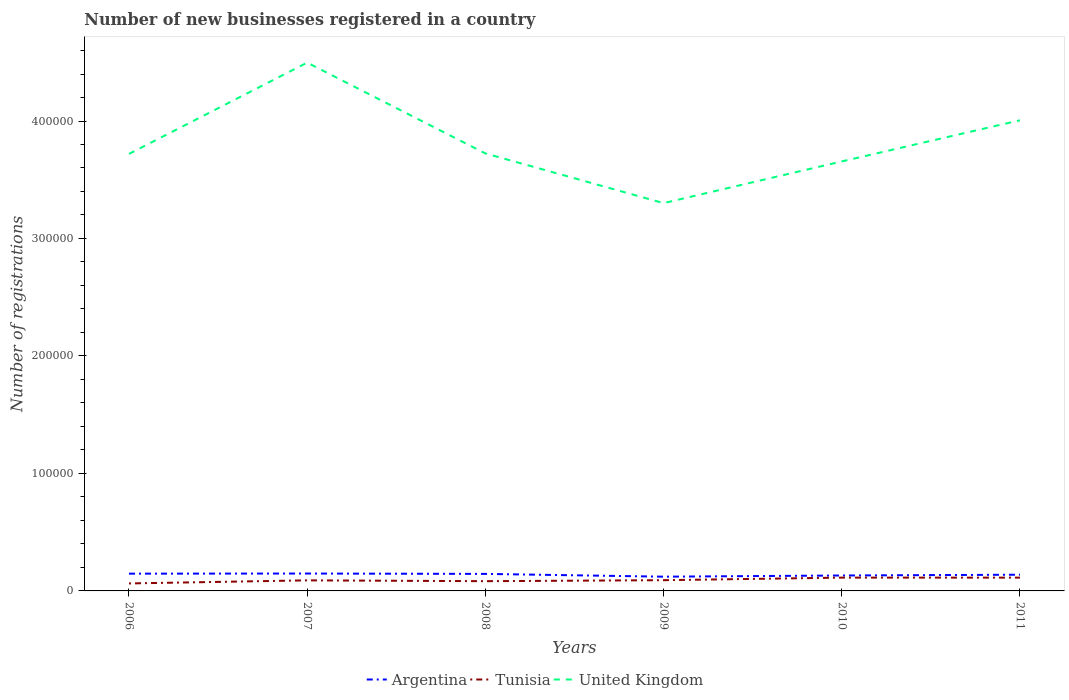Across all years, what is the maximum number of new businesses registered in Tunisia?
Give a very brief answer. 6368. In which year was the number of new businesses registered in United Kingdom maximum?
Provide a short and direct response. 2009. What is the total number of new businesses registered in Tunisia in the graph?
Your response must be concise. -841. What is the difference between the highest and the second highest number of new businesses registered in Argentina?
Provide a succinct answer. 2687. How are the legend labels stacked?
Offer a terse response. Horizontal. What is the title of the graph?
Ensure brevity in your answer.  Number of new businesses registered in a country. Does "New Caledonia" appear as one of the legend labels in the graph?
Give a very brief answer. No. What is the label or title of the Y-axis?
Your answer should be very brief. Number of registrations. What is the Number of registrations of Argentina in 2006?
Give a very brief answer. 1.47e+04. What is the Number of registrations of Tunisia in 2006?
Make the answer very short. 6368. What is the Number of registrations in United Kingdom in 2006?
Ensure brevity in your answer.  3.72e+05. What is the Number of registrations in Argentina in 2007?
Provide a short and direct response. 1.48e+04. What is the Number of registrations of Tunisia in 2007?
Your answer should be compact. 8997. What is the Number of registrations of United Kingdom in 2007?
Offer a very short reply. 4.50e+05. What is the Number of registrations in Argentina in 2008?
Your answer should be very brief. 1.45e+04. What is the Number of registrations in Tunisia in 2008?
Keep it short and to the point. 8297. What is the Number of registrations in United Kingdom in 2008?
Keep it short and to the point. 3.72e+05. What is the Number of registrations of Argentina in 2009?
Give a very brief answer. 1.21e+04. What is the Number of registrations in Tunisia in 2009?
Make the answer very short. 9138. What is the Number of registrations in United Kingdom in 2009?
Keep it short and to the point. 3.30e+05. What is the Number of registrations of Argentina in 2010?
Give a very brief answer. 1.31e+04. What is the Number of registrations of Tunisia in 2010?
Offer a very short reply. 1.13e+04. What is the Number of registrations of United Kingdom in 2010?
Keep it short and to the point. 3.66e+05. What is the Number of registrations in Argentina in 2011?
Offer a very short reply. 1.38e+04. What is the Number of registrations in Tunisia in 2011?
Offer a terse response. 1.13e+04. What is the Number of registrations in United Kingdom in 2011?
Your response must be concise. 4.01e+05. Across all years, what is the maximum Number of registrations in Argentina?
Make the answer very short. 1.48e+04. Across all years, what is the maximum Number of registrations in Tunisia?
Provide a short and direct response. 1.13e+04. Across all years, what is the maximum Number of registrations of United Kingdom?
Provide a succinct answer. 4.50e+05. Across all years, what is the minimum Number of registrations of Argentina?
Provide a succinct answer. 1.21e+04. Across all years, what is the minimum Number of registrations in Tunisia?
Offer a very short reply. 6368. Across all years, what is the minimum Number of registrations of United Kingdom?
Your answer should be compact. 3.30e+05. What is the total Number of registrations in Argentina in the graph?
Offer a terse response. 8.30e+04. What is the total Number of registrations in Tunisia in the graph?
Offer a very short reply. 5.54e+04. What is the total Number of registrations of United Kingdom in the graph?
Your answer should be compact. 2.29e+06. What is the difference between the Number of registrations of Argentina in 2006 and that in 2007?
Your answer should be very brief. -111. What is the difference between the Number of registrations of Tunisia in 2006 and that in 2007?
Your response must be concise. -2629. What is the difference between the Number of registrations in United Kingdom in 2006 and that in 2007?
Give a very brief answer. -7.77e+04. What is the difference between the Number of registrations in Argentina in 2006 and that in 2008?
Your response must be concise. 201. What is the difference between the Number of registrations in Tunisia in 2006 and that in 2008?
Provide a short and direct response. -1929. What is the difference between the Number of registrations of United Kingdom in 2006 and that in 2008?
Give a very brief answer. -400. What is the difference between the Number of registrations in Argentina in 2006 and that in 2009?
Your answer should be very brief. 2576. What is the difference between the Number of registrations of Tunisia in 2006 and that in 2009?
Ensure brevity in your answer.  -2770. What is the difference between the Number of registrations in United Kingdom in 2006 and that in 2009?
Keep it short and to the point. 4.19e+04. What is the difference between the Number of registrations in Argentina in 2006 and that in 2010?
Your answer should be very brief. 1561. What is the difference between the Number of registrations of Tunisia in 2006 and that in 2010?
Your answer should be compact. -4949. What is the difference between the Number of registrations of United Kingdom in 2006 and that in 2010?
Provide a succinct answer. 6400. What is the difference between the Number of registrations in Argentina in 2006 and that in 2011?
Offer a terse response. 895. What is the difference between the Number of registrations of Tunisia in 2006 and that in 2011?
Your answer should be compact. -4939. What is the difference between the Number of registrations in United Kingdom in 2006 and that in 2011?
Ensure brevity in your answer.  -2.86e+04. What is the difference between the Number of registrations in Argentina in 2007 and that in 2008?
Ensure brevity in your answer.  312. What is the difference between the Number of registrations of Tunisia in 2007 and that in 2008?
Your response must be concise. 700. What is the difference between the Number of registrations in United Kingdom in 2007 and that in 2008?
Keep it short and to the point. 7.73e+04. What is the difference between the Number of registrations in Argentina in 2007 and that in 2009?
Your response must be concise. 2687. What is the difference between the Number of registrations of Tunisia in 2007 and that in 2009?
Make the answer very short. -141. What is the difference between the Number of registrations of United Kingdom in 2007 and that in 2009?
Give a very brief answer. 1.20e+05. What is the difference between the Number of registrations in Argentina in 2007 and that in 2010?
Offer a very short reply. 1672. What is the difference between the Number of registrations in Tunisia in 2007 and that in 2010?
Provide a short and direct response. -2320. What is the difference between the Number of registrations of United Kingdom in 2007 and that in 2010?
Your answer should be very brief. 8.41e+04. What is the difference between the Number of registrations in Argentina in 2007 and that in 2011?
Offer a terse response. 1006. What is the difference between the Number of registrations in Tunisia in 2007 and that in 2011?
Your answer should be compact. -2310. What is the difference between the Number of registrations of United Kingdom in 2007 and that in 2011?
Provide a succinct answer. 4.91e+04. What is the difference between the Number of registrations in Argentina in 2008 and that in 2009?
Your answer should be very brief. 2375. What is the difference between the Number of registrations in Tunisia in 2008 and that in 2009?
Offer a very short reply. -841. What is the difference between the Number of registrations of United Kingdom in 2008 and that in 2009?
Ensure brevity in your answer.  4.23e+04. What is the difference between the Number of registrations of Argentina in 2008 and that in 2010?
Provide a succinct answer. 1360. What is the difference between the Number of registrations of Tunisia in 2008 and that in 2010?
Give a very brief answer. -3020. What is the difference between the Number of registrations in United Kingdom in 2008 and that in 2010?
Give a very brief answer. 6800. What is the difference between the Number of registrations of Argentina in 2008 and that in 2011?
Provide a short and direct response. 694. What is the difference between the Number of registrations of Tunisia in 2008 and that in 2011?
Provide a short and direct response. -3010. What is the difference between the Number of registrations of United Kingdom in 2008 and that in 2011?
Your answer should be very brief. -2.82e+04. What is the difference between the Number of registrations in Argentina in 2009 and that in 2010?
Offer a terse response. -1015. What is the difference between the Number of registrations of Tunisia in 2009 and that in 2010?
Provide a succinct answer. -2179. What is the difference between the Number of registrations of United Kingdom in 2009 and that in 2010?
Your answer should be very brief. -3.55e+04. What is the difference between the Number of registrations of Argentina in 2009 and that in 2011?
Your answer should be very brief. -1681. What is the difference between the Number of registrations in Tunisia in 2009 and that in 2011?
Make the answer very short. -2169. What is the difference between the Number of registrations in United Kingdom in 2009 and that in 2011?
Ensure brevity in your answer.  -7.05e+04. What is the difference between the Number of registrations in Argentina in 2010 and that in 2011?
Offer a very short reply. -666. What is the difference between the Number of registrations in United Kingdom in 2010 and that in 2011?
Ensure brevity in your answer.  -3.50e+04. What is the difference between the Number of registrations of Argentina in 2006 and the Number of registrations of Tunisia in 2007?
Give a very brief answer. 5697. What is the difference between the Number of registrations in Argentina in 2006 and the Number of registrations in United Kingdom in 2007?
Offer a terse response. -4.35e+05. What is the difference between the Number of registrations of Tunisia in 2006 and the Number of registrations of United Kingdom in 2007?
Make the answer very short. -4.43e+05. What is the difference between the Number of registrations in Argentina in 2006 and the Number of registrations in Tunisia in 2008?
Your answer should be compact. 6397. What is the difference between the Number of registrations in Argentina in 2006 and the Number of registrations in United Kingdom in 2008?
Offer a terse response. -3.58e+05. What is the difference between the Number of registrations in Tunisia in 2006 and the Number of registrations in United Kingdom in 2008?
Offer a very short reply. -3.66e+05. What is the difference between the Number of registrations in Argentina in 2006 and the Number of registrations in Tunisia in 2009?
Your answer should be compact. 5556. What is the difference between the Number of registrations of Argentina in 2006 and the Number of registrations of United Kingdom in 2009?
Offer a very short reply. -3.15e+05. What is the difference between the Number of registrations of Tunisia in 2006 and the Number of registrations of United Kingdom in 2009?
Your answer should be very brief. -3.24e+05. What is the difference between the Number of registrations in Argentina in 2006 and the Number of registrations in Tunisia in 2010?
Provide a short and direct response. 3377. What is the difference between the Number of registrations of Argentina in 2006 and the Number of registrations of United Kingdom in 2010?
Offer a very short reply. -3.51e+05. What is the difference between the Number of registrations of Tunisia in 2006 and the Number of registrations of United Kingdom in 2010?
Your answer should be very brief. -3.59e+05. What is the difference between the Number of registrations in Argentina in 2006 and the Number of registrations in Tunisia in 2011?
Offer a very short reply. 3387. What is the difference between the Number of registrations of Argentina in 2006 and the Number of registrations of United Kingdom in 2011?
Provide a succinct answer. -3.86e+05. What is the difference between the Number of registrations of Tunisia in 2006 and the Number of registrations of United Kingdom in 2011?
Your answer should be compact. -3.94e+05. What is the difference between the Number of registrations of Argentina in 2007 and the Number of registrations of Tunisia in 2008?
Offer a very short reply. 6508. What is the difference between the Number of registrations of Argentina in 2007 and the Number of registrations of United Kingdom in 2008?
Provide a short and direct response. -3.58e+05. What is the difference between the Number of registrations of Tunisia in 2007 and the Number of registrations of United Kingdom in 2008?
Your response must be concise. -3.63e+05. What is the difference between the Number of registrations in Argentina in 2007 and the Number of registrations in Tunisia in 2009?
Provide a short and direct response. 5667. What is the difference between the Number of registrations of Argentina in 2007 and the Number of registrations of United Kingdom in 2009?
Provide a succinct answer. -3.15e+05. What is the difference between the Number of registrations in Tunisia in 2007 and the Number of registrations in United Kingdom in 2009?
Keep it short and to the point. -3.21e+05. What is the difference between the Number of registrations of Argentina in 2007 and the Number of registrations of Tunisia in 2010?
Give a very brief answer. 3488. What is the difference between the Number of registrations of Argentina in 2007 and the Number of registrations of United Kingdom in 2010?
Offer a very short reply. -3.51e+05. What is the difference between the Number of registrations of Tunisia in 2007 and the Number of registrations of United Kingdom in 2010?
Make the answer very short. -3.57e+05. What is the difference between the Number of registrations of Argentina in 2007 and the Number of registrations of Tunisia in 2011?
Your response must be concise. 3498. What is the difference between the Number of registrations in Argentina in 2007 and the Number of registrations in United Kingdom in 2011?
Your answer should be very brief. -3.86e+05. What is the difference between the Number of registrations of Tunisia in 2007 and the Number of registrations of United Kingdom in 2011?
Your answer should be compact. -3.92e+05. What is the difference between the Number of registrations in Argentina in 2008 and the Number of registrations in Tunisia in 2009?
Provide a succinct answer. 5355. What is the difference between the Number of registrations of Argentina in 2008 and the Number of registrations of United Kingdom in 2009?
Keep it short and to the point. -3.16e+05. What is the difference between the Number of registrations in Tunisia in 2008 and the Number of registrations in United Kingdom in 2009?
Your answer should be very brief. -3.22e+05. What is the difference between the Number of registrations in Argentina in 2008 and the Number of registrations in Tunisia in 2010?
Your response must be concise. 3176. What is the difference between the Number of registrations in Argentina in 2008 and the Number of registrations in United Kingdom in 2010?
Offer a very short reply. -3.51e+05. What is the difference between the Number of registrations in Tunisia in 2008 and the Number of registrations in United Kingdom in 2010?
Offer a very short reply. -3.57e+05. What is the difference between the Number of registrations in Argentina in 2008 and the Number of registrations in Tunisia in 2011?
Ensure brevity in your answer.  3186. What is the difference between the Number of registrations in Argentina in 2008 and the Number of registrations in United Kingdom in 2011?
Ensure brevity in your answer.  -3.86e+05. What is the difference between the Number of registrations in Tunisia in 2008 and the Number of registrations in United Kingdom in 2011?
Provide a succinct answer. -3.92e+05. What is the difference between the Number of registrations in Argentina in 2009 and the Number of registrations in Tunisia in 2010?
Offer a very short reply. 801. What is the difference between the Number of registrations of Argentina in 2009 and the Number of registrations of United Kingdom in 2010?
Your response must be concise. -3.53e+05. What is the difference between the Number of registrations in Tunisia in 2009 and the Number of registrations in United Kingdom in 2010?
Give a very brief answer. -3.56e+05. What is the difference between the Number of registrations in Argentina in 2009 and the Number of registrations in Tunisia in 2011?
Your response must be concise. 811. What is the difference between the Number of registrations of Argentina in 2009 and the Number of registrations of United Kingdom in 2011?
Your response must be concise. -3.88e+05. What is the difference between the Number of registrations of Tunisia in 2009 and the Number of registrations of United Kingdom in 2011?
Offer a very short reply. -3.91e+05. What is the difference between the Number of registrations in Argentina in 2010 and the Number of registrations in Tunisia in 2011?
Ensure brevity in your answer.  1826. What is the difference between the Number of registrations of Argentina in 2010 and the Number of registrations of United Kingdom in 2011?
Provide a succinct answer. -3.87e+05. What is the difference between the Number of registrations of Tunisia in 2010 and the Number of registrations of United Kingdom in 2011?
Keep it short and to the point. -3.89e+05. What is the average Number of registrations in Argentina per year?
Provide a succinct answer. 1.38e+04. What is the average Number of registrations in Tunisia per year?
Provide a short and direct response. 9237.33. What is the average Number of registrations in United Kingdom per year?
Your answer should be very brief. 3.82e+05. In the year 2006, what is the difference between the Number of registrations of Argentina and Number of registrations of Tunisia?
Keep it short and to the point. 8326. In the year 2006, what is the difference between the Number of registrations in Argentina and Number of registrations in United Kingdom?
Your response must be concise. -3.57e+05. In the year 2006, what is the difference between the Number of registrations of Tunisia and Number of registrations of United Kingdom?
Provide a short and direct response. -3.66e+05. In the year 2007, what is the difference between the Number of registrations in Argentina and Number of registrations in Tunisia?
Provide a succinct answer. 5808. In the year 2007, what is the difference between the Number of registrations in Argentina and Number of registrations in United Kingdom?
Ensure brevity in your answer.  -4.35e+05. In the year 2007, what is the difference between the Number of registrations in Tunisia and Number of registrations in United Kingdom?
Provide a succinct answer. -4.41e+05. In the year 2008, what is the difference between the Number of registrations in Argentina and Number of registrations in Tunisia?
Your answer should be compact. 6196. In the year 2008, what is the difference between the Number of registrations in Argentina and Number of registrations in United Kingdom?
Your response must be concise. -3.58e+05. In the year 2008, what is the difference between the Number of registrations in Tunisia and Number of registrations in United Kingdom?
Provide a short and direct response. -3.64e+05. In the year 2009, what is the difference between the Number of registrations of Argentina and Number of registrations of Tunisia?
Provide a short and direct response. 2980. In the year 2009, what is the difference between the Number of registrations in Argentina and Number of registrations in United Kingdom?
Keep it short and to the point. -3.18e+05. In the year 2009, what is the difference between the Number of registrations of Tunisia and Number of registrations of United Kingdom?
Provide a short and direct response. -3.21e+05. In the year 2010, what is the difference between the Number of registrations of Argentina and Number of registrations of Tunisia?
Offer a very short reply. 1816. In the year 2010, what is the difference between the Number of registrations in Argentina and Number of registrations in United Kingdom?
Provide a succinct answer. -3.52e+05. In the year 2010, what is the difference between the Number of registrations of Tunisia and Number of registrations of United Kingdom?
Offer a very short reply. -3.54e+05. In the year 2011, what is the difference between the Number of registrations of Argentina and Number of registrations of Tunisia?
Provide a short and direct response. 2492. In the year 2011, what is the difference between the Number of registrations of Argentina and Number of registrations of United Kingdom?
Ensure brevity in your answer.  -3.87e+05. In the year 2011, what is the difference between the Number of registrations in Tunisia and Number of registrations in United Kingdom?
Ensure brevity in your answer.  -3.89e+05. What is the ratio of the Number of registrations of Argentina in 2006 to that in 2007?
Keep it short and to the point. 0.99. What is the ratio of the Number of registrations of Tunisia in 2006 to that in 2007?
Provide a short and direct response. 0.71. What is the ratio of the Number of registrations of United Kingdom in 2006 to that in 2007?
Offer a terse response. 0.83. What is the ratio of the Number of registrations of Argentina in 2006 to that in 2008?
Your answer should be very brief. 1.01. What is the ratio of the Number of registrations of Tunisia in 2006 to that in 2008?
Offer a very short reply. 0.77. What is the ratio of the Number of registrations in United Kingdom in 2006 to that in 2008?
Give a very brief answer. 1. What is the ratio of the Number of registrations in Argentina in 2006 to that in 2009?
Provide a succinct answer. 1.21. What is the ratio of the Number of registrations of Tunisia in 2006 to that in 2009?
Make the answer very short. 0.7. What is the ratio of the Number of registrations in United Kingdom in 2006 to that in 2009?
Your answer should be compact. 1.13. What is the ratio of the Number of registrations in Argentina in 2006 to that in 2010?
Make the answer very short. 1.12. What is the ratio of the Number of registrations in Tunisia in 2006 to that in 2010?
Provide a succinct answer. 0.56. What is the ratio of the Number of registrations in United Kingdom in 2006 to that in 2010?
Give a very brief answer. 1.02. What is the ratio of the Number of registrations in Argentina in 2006 to that in 2011?
Keep it short and to the point. 1.06. What is the ratio of the Number of registrations in Tunisia in 2006 to that in 2011?
Ensure brevity in your answer.  0.56. What is the ratio of the Number of registrations of Argentina in 2007 to that in 2008?
Ensure brevity in your answer.  1.02. What is the ratio of the Number of registrations in Tunisia in 2007 to that in 2008?
Give a very brief answer. 1.08. What is the ratio of the Number of registrations in United Kingdom in 2007 to that in 2008?
Make the answer very short. 1.21. What is the ratio of the Number of registrations in Argentina in 2007 to that in 2009?
Give a very brief answer. 1.22. What is the ratio of the Number of registrations of Tunisia in 2007 to that in 2009?
Make the answer very short. 0.98. What is the ratio of the Number of registrations in United Kingdom in 2007 to that in 2009?
Provide a succinct answer. 1.36. What is the ratio of the Number of registrations in Argentina in 2007 to that in 2010?
Offer a very short reply. 1.13. What is the ratio of the Number of registrations in Tunisia in 2007 to that in 2010?
Keep it short and to the point. 0.8. What is the ratio of the Number of registrations in United Kingdom in 2007 to that in 2010?
Provide a short and direct response. 1.23. What is the ratio of the Number of registrations in Argentina in 2007 to that in 2011?
Your answer should be compact. 1.07. What is the ratio of the Number of registrations of Tunisia in 2007 to that in 2011?
Ensure brevity in your answer.  0.8. What is the ratio of the Number of registrations in United Kingdom in 2007 to that in 2011?
Your answer should be very brief. 1.12. What is the ratio of the Number of registrations in Argentina in 2008 to that in 2009?
Give a very brief answer. 1.2. What is the ratio of the Number of registrations in Tunisia in 2008 to that in 2009?
Your answer should be compact. 0.91. What is the ratio of the Number of registrations in United Kingdom in 2008 to that in 2009?
Ensure brevity in your answer.  1.13. What is the ratio of the Number of registrations of Argentina in 2008 to that in 2010?
Offer a terse response. 1.1. What is the ratio of the Number of registrations in Tunisia in 2008 to that in 2010?
Your answer should be very brief. 0.73. What is the ratio of the Number of registrations of United Kingdom in 2008 to that in 2010?
Make the answer very short. 1.02. What is the ratio of the Number of registrations of Argentina in 2008 to that in 2011?
Provide a short and direct response. 1.05. What is the ratio of the Number of registrations of Tunisia in 2008 to that in 2011?
Offer a very short reply. 0.73. What is the ratio of the Number of registrations of United Kingdom in 2008 to that in 2011?
Offer a very short reply. 0.93. What is the ratio of the Number of registrations in Argentina in 2009 to that in 2010?
Your response must be concise. 0.92. What is the ratio of the Number of registrations in Tunisia in 2009 to that in 2010?
Give a very brief answer. 0.81. What is the ratio of the Number of registrations in United Kingdom in 2009 to that in 2010?
Ensure brevity in your answer.  0.9. What is the ratio of the Number of registrations of Argentina in 2009 to that in 2011?
Make the answer very short. 0.88. What is the ratio of the Number of registrations in Tunisia in 2009 to that in 2011?
Offer a very short reply. 0.81. What is the ratio of the Number of registrations in United Kingdom in 2009 to that in 2011?
Your response must be concise. 0.82. What is the ratio of the Number of registrations in Argentina in 2010 to that in 2011?
Your response must be concise. 0.95. What is the ratio of the Number of registrations of United Kingdom in 2010 to that in 2011?
Your answer should be very brief. 0.91. What is the difference between the highest and the second highest Number of registrations of Argentina?
Your response must be concise. 111. What is the difference between the highest and the second highest Number of registrations in Tunisia?
Give a very brief answer. 10. What is the difference between the highest and the second highest Number of registrations in United Kingdom?
Your answer should be very brief. 4.91e+04. What is the difference between the highest and the lowest Number of registrations of Argentina?
Your answer should be very brief. 2687. What is the difference between the highest and the lowest Number of registrations of Tunisia?
Your answer should be very brief. 4949. What is the difference between the highest and the lowest Number of registrations of United Kingdom?
Your answer should be compact. 1.20e+05. 